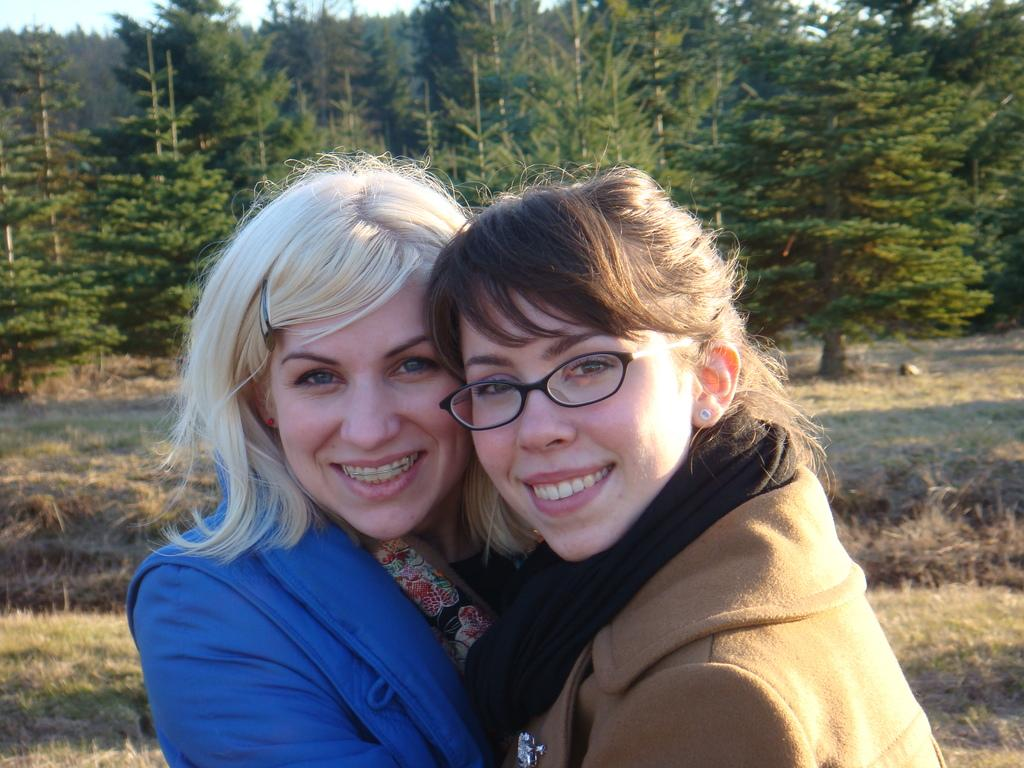How many people are in the image? There are two women in the image. What are the women standing on? The women are standing on the grass. What can be seen in the background of the image? There are trees visible in the background of the image. What type of vegetable is the women using to make a decision in the image? There is no vegetable present in the image, nor is there any indication that the women are making a decision. 